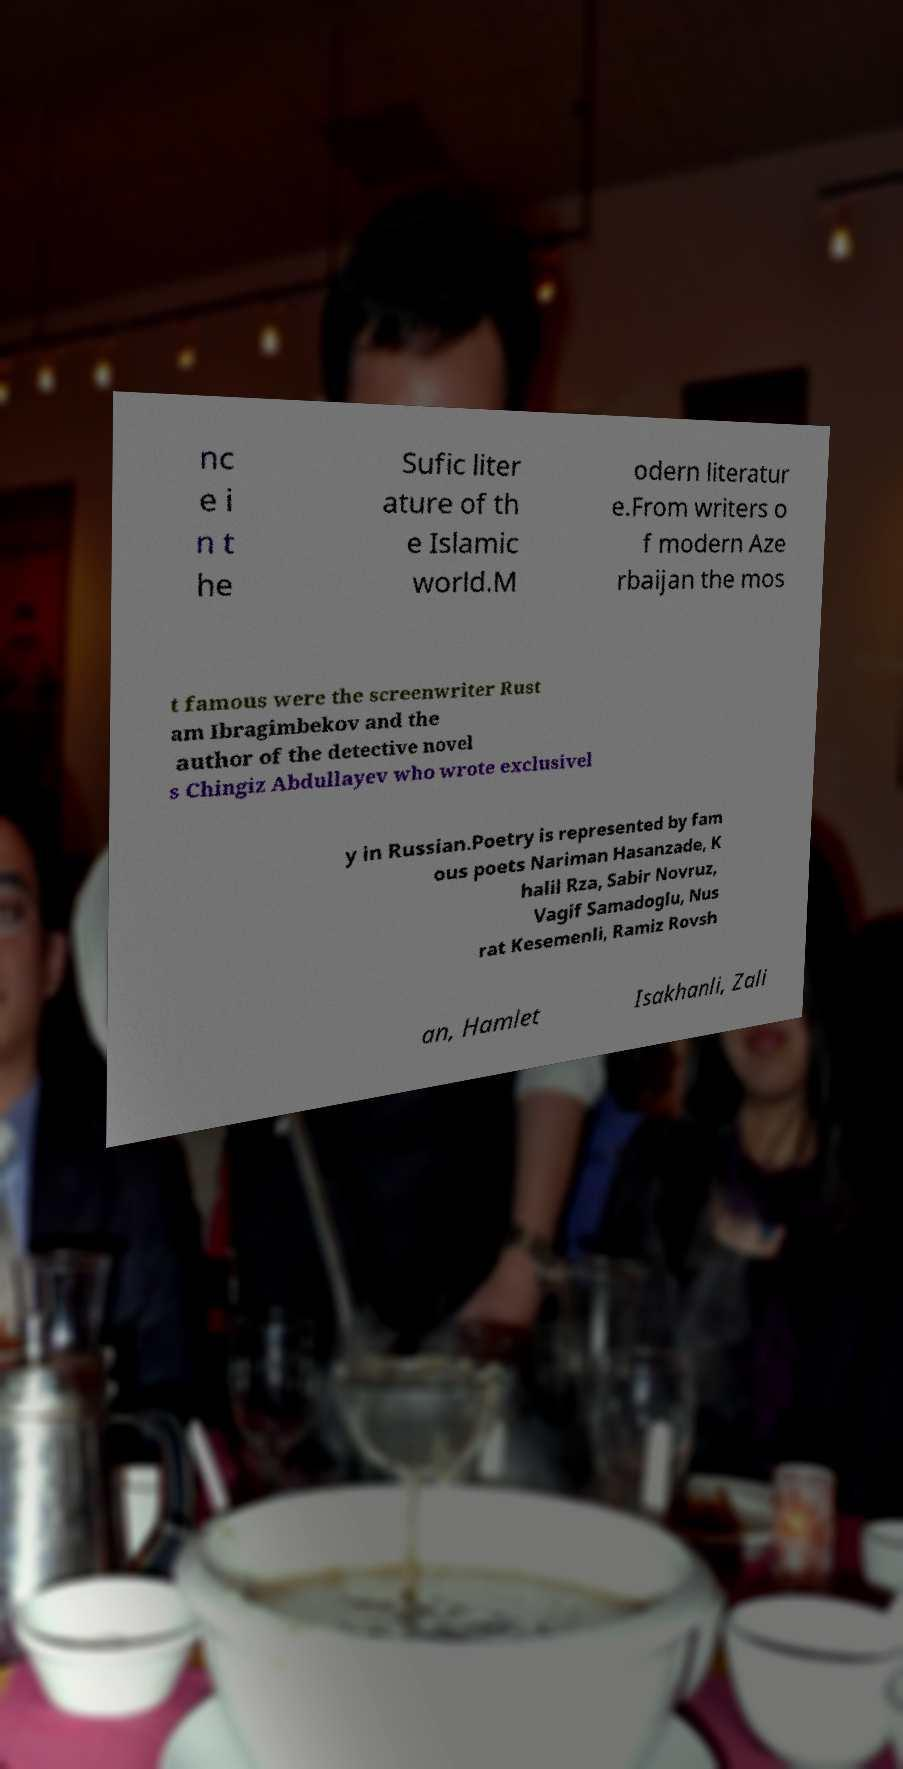Please read and relay the text visible in this image. What does it say? nc e i n t he Sufic liter ature of th e Islamic world.M odern literatur e.From writers o f modern Aze rbaijan the mos t famous were the screenwriter Rust am Ibragimbekov and the author of the detective novel s Chingiz Abdullayev who wrote exclusivel y in Russian.Poetry is represented by fam ous poets Nariman Hasanzade, K halil Rza, Sabir Novruz, Vagif Samadoglu, Nus rat Kesemenli, Ramiz Rovsh an, Hamlet Isakhanli, Zali 